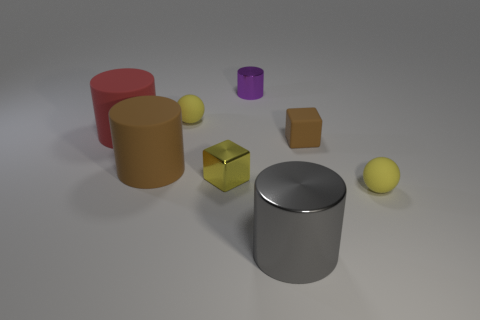What is the shape of the yellow thing that is behind the large brown rubber cylinder to the left of the tiny metallic object that is behind the matte cube?
Offer a terse response. Sphere. Does the small purple object that is on the right side of the red rubber cylinder have the same material as the tiny sphere that is behind the brown rubber cube?
Give a very brief answer. No. What material is the gray thing that is the same shape as the large red rubber thing?
Provide a succinct answer. Metal. Do the small yellow matte thing that is behind the large red thing and the tiny metal thing in front of the large red cylinder have the same shape?
Offer a very short reply. No. Is the number of small purple cylinders that are in front of the tiny purple shiny thing less than the number of tiny brown matte objects that are behind the shiny cube?
Keep it short and to the point. Yes. How many other things are there of the same shape as the small brown object?
Give a very brief answer. 1. What shape is the small thing that is made of the same material as the purple cylinder?
Your answer should be compact. Cube. What color is the thing that is on the right side of the gray cylinder and in front of the small yellow cube?
Keep it short and to the point. Yellow. Do the tiny yellow ball that is behind the red matte thing and the tiny yellow block have the same material?
Offer a terse response. No. Are there fewer matte balls that are right of the gray shiny cylinder than matte spheres?
Provide a succinct answer. Yes. 